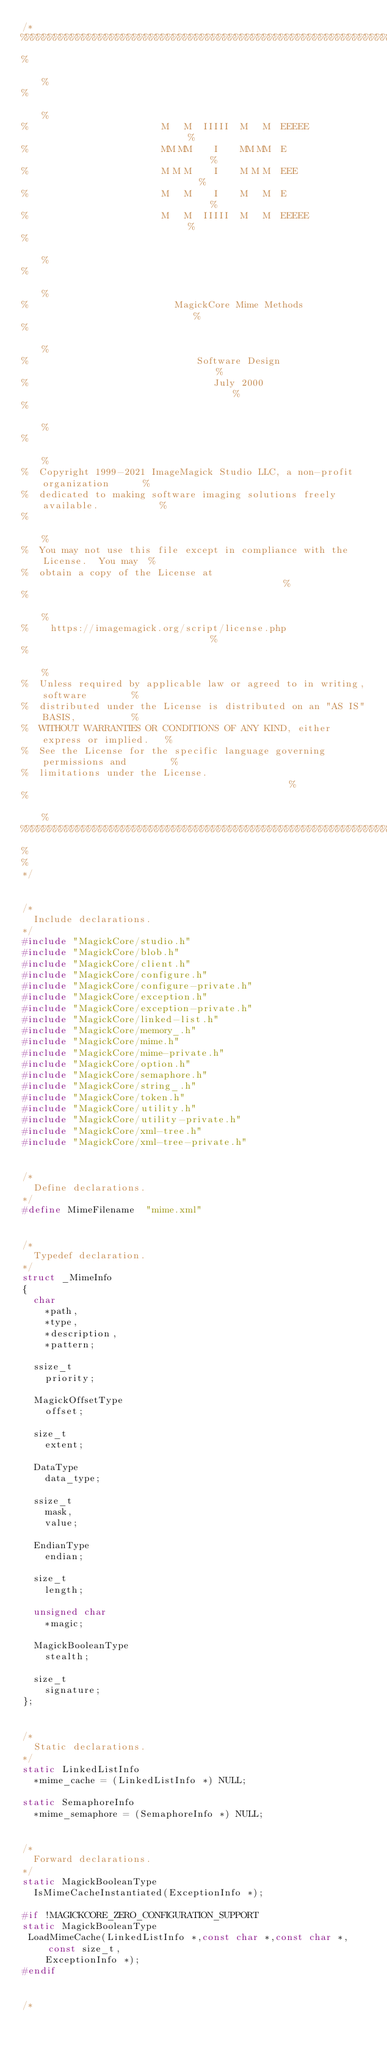Convert code to text. <code><loc_0><loc_0><loc_500><loc_500><_C_>/*
%%%%%%%%%%%%%%%%%%%%%%%%%%%%%%%%%%%%%%%%%%%%%%%%%%%%%%%%%%%%%%%%%%%%%%%%%%%%%%%
%                                                                             %
%                                                                             %
%                        M   M  IIIII  M   M  EEEEE                           %
%                        MM MM    I    MM MM  E                               %
%                        M M M    I    M M M  EEE                             %
%                        M   M    I    M   M  E                               %
%                        M   M  IIIII  M   M  EEEEE                           %
%                                                                             %
%                                                                             %
%                          MagickCore Mime Methods                            %
%                                                                             %
%                              Software Design                                %
%                                 July 2000                                   %
%                                                                             %
%                                                                             %
%  Copyright 1999-2021 ImageMagick Studio LLC, a non-profit organization      %
%  dedicated to making software imaging solutions freely available.           %
%                                                                             %
%  You may not use this file except in compliance with the License.  You may  %
%  obtain a copy of the License at                                            %
%                                                                             %
%    https://imagemagick.org/script/license.php                               %
%                                                                             %
%  Unless required by applicable law or agreed to in writing, software        %
%  distributed under the License is distributed on an "AS IS" BASIS,          %
%  WITHOUT WARRANTIES OR CONDITIONS OF ANY KIND, either express or implied.   %
%  See the License for the specific language governing permissions and        %
%  limitations under the License.                                             %
%                                                                             %
%%%%%%%%%%%%%%%%%%%%%%%%%%%%%%%%%%%%%%%%%%%%%%%%%%%%%%%%%%%%%%%%%%%%%%%%%%%%%%%
%
%
*/

/*
  Include declarations.
*/
#include "MagickCore/studio.h"
#include "MagickCore/blob.h"
#include "MagickCore/client.h"
#include "MagickCore/configure.h"
#include "MagickCore/configure-private.h"
#include "MagickCore/exception.h"
#include "MagickCore/exception-private.h"
#include "MagickCore/linked-list.h"
#include "MagickCore/memory_.h"
#include "MagickCore/mime.h"
#include "MagickCore/mime-private.h"
#include "MagickCore/option.h"
#include "MagickCore/semaphore.h"
#include "MagickCore/string_.h"
#include "MagickCore/token.h"
#include "MagickCore/utility.h"
#include "MagickCore/utility-private.h"
#include "MagickCore/xml-tree.h"
#include "MagickCore/xml-tree-private.h"

/*
  Define declarations.
*/
#define MimeFilename  "mime.xml"

/*
  Typedef declaration.
*/
struct _MimeInfo
{
  char
    *path,
    *type,
    *description,
    *pattern;

  ssize_t
    priority;

  MagickOffsetType
    offset;

  size_t
    extent;

  DataType
    data_type;

  ssize_t
    mask,
    value;

  EndianType
    endian;

  size_t
    length;

  unsigned char
    *magic;

  MagickBooleanType
    stealth;

  size_t
    signature;
};

/*
  Static declarations.
*/
static LinkedListInfo
  *mime_cache = (LinkedListInfo *) NULL;

static SemaphoreInfo
  *mime_semaphore = (SemaphoreInfo *) NULL;

/*
  Forward declarations.
*/
static MagickBooleanType
  IsMimeCacheInstantiated(ExceptionInfo *);

#if !MAGICKCORE_ZERO_CONFIGURATION_SUPPORT
static MagickBooleanType
 LoadMimeCache(LinkedListInfo *,const char *,const char *,const size_t,
    ExceptionInfo *);
#endif

/*</code> 